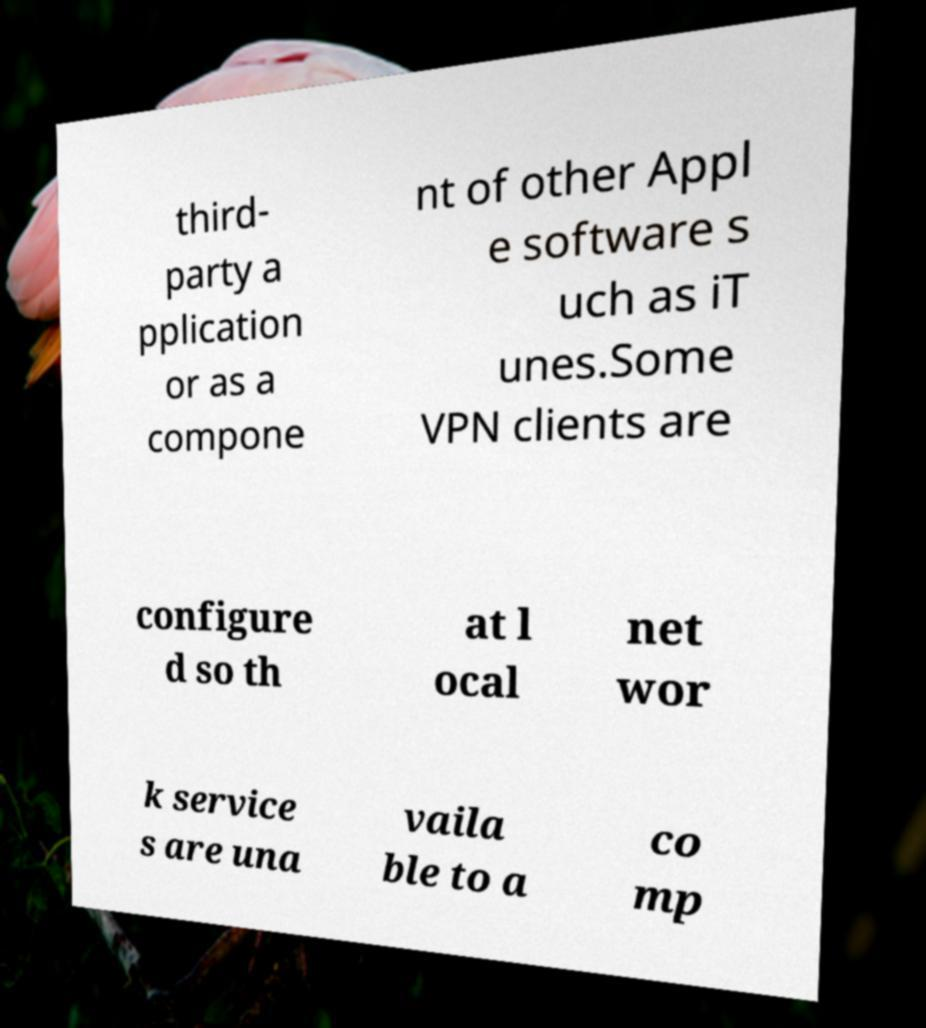Could you assist in decoding the text presented in this image and type it out clearly? third- party a pplication or as a compone nt of other Appl e software s uch as iT unes.Some VPN clients are configure d so th at l ocal net wor k service s are una vaila ble to a co mp 